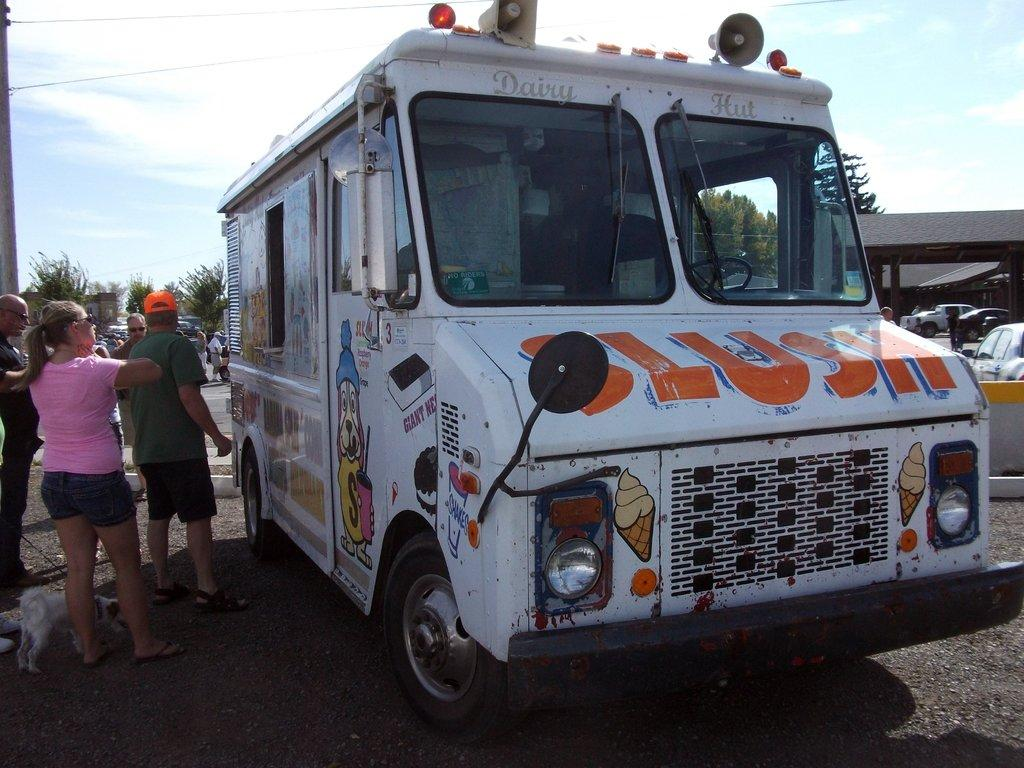What type of vehicle is in the image? There is a truck in the image. Who or what else is present in the image? There is a group of people, trees, vehicles, buildings, a shelter, a dog, and a pole in the image. Can you describe the setting of the image? The image features a truck, people, trees, vehicles, buildings, a shelter, a dog, and a pole, with the sky visible in the background. What type of brush can be seen in the image? There is no brush present in the image. Is there any quicksand visible in the image? There is no quicksand present in the image. 